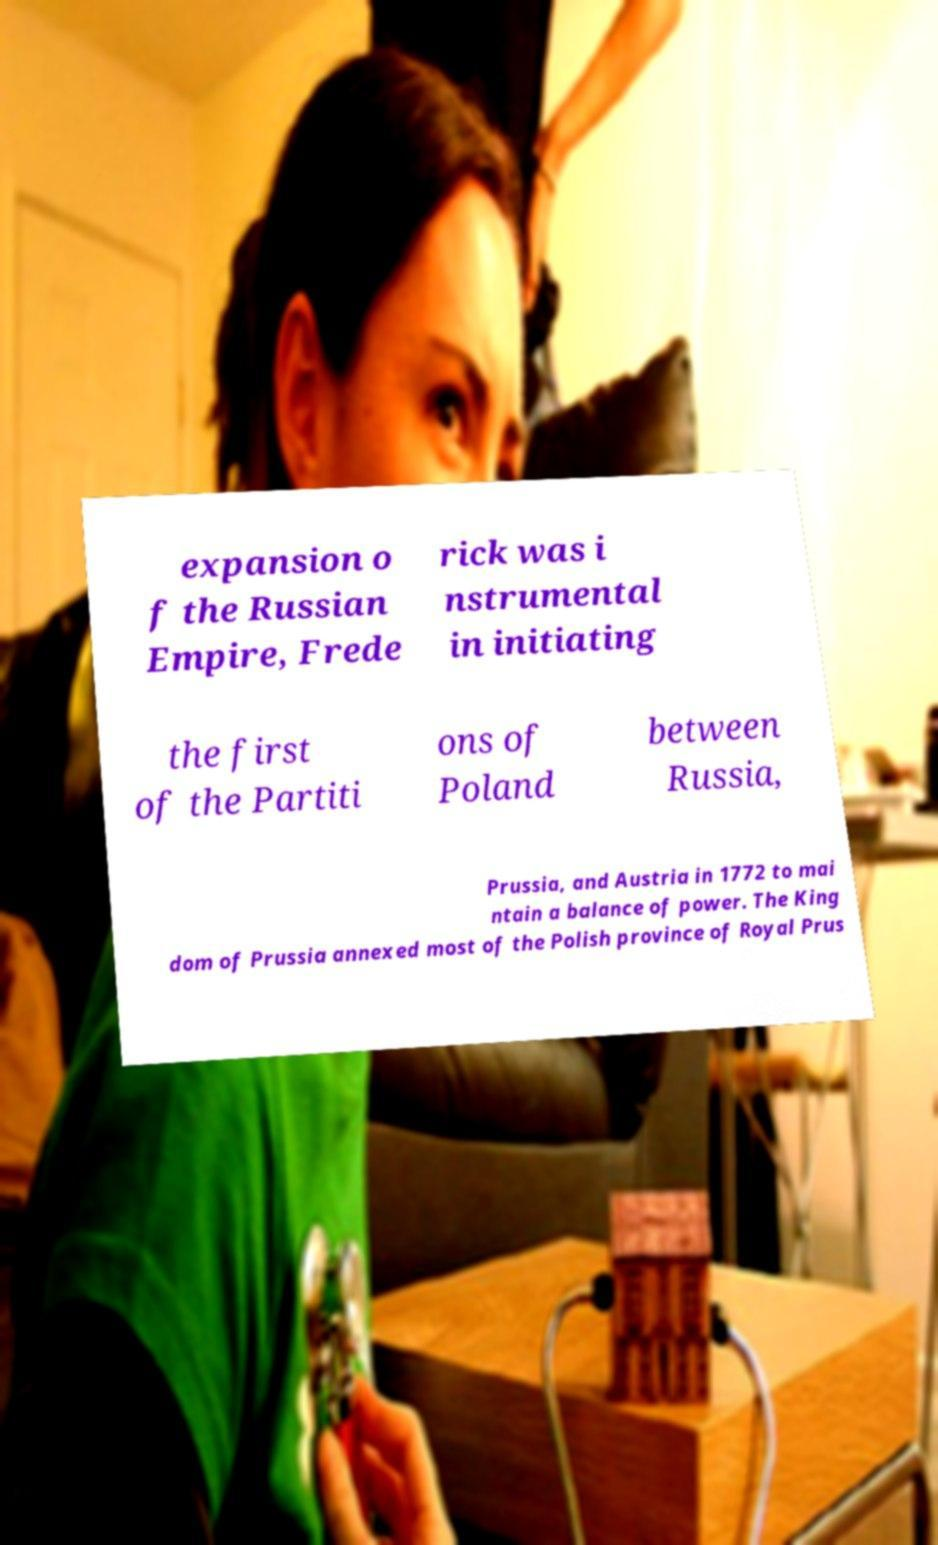Could you assist in decoding the text presented in this image and type it out clearly? expansion o f the Russian Empire, Frede rick was i nstrumental in initiating the first of the Partiti ons of Poland between Russia, Prussia, and Austria in 1772 to mai ntain a balance of power. The King dom of Prussia annexed most of the Polish province of Royal Prus 